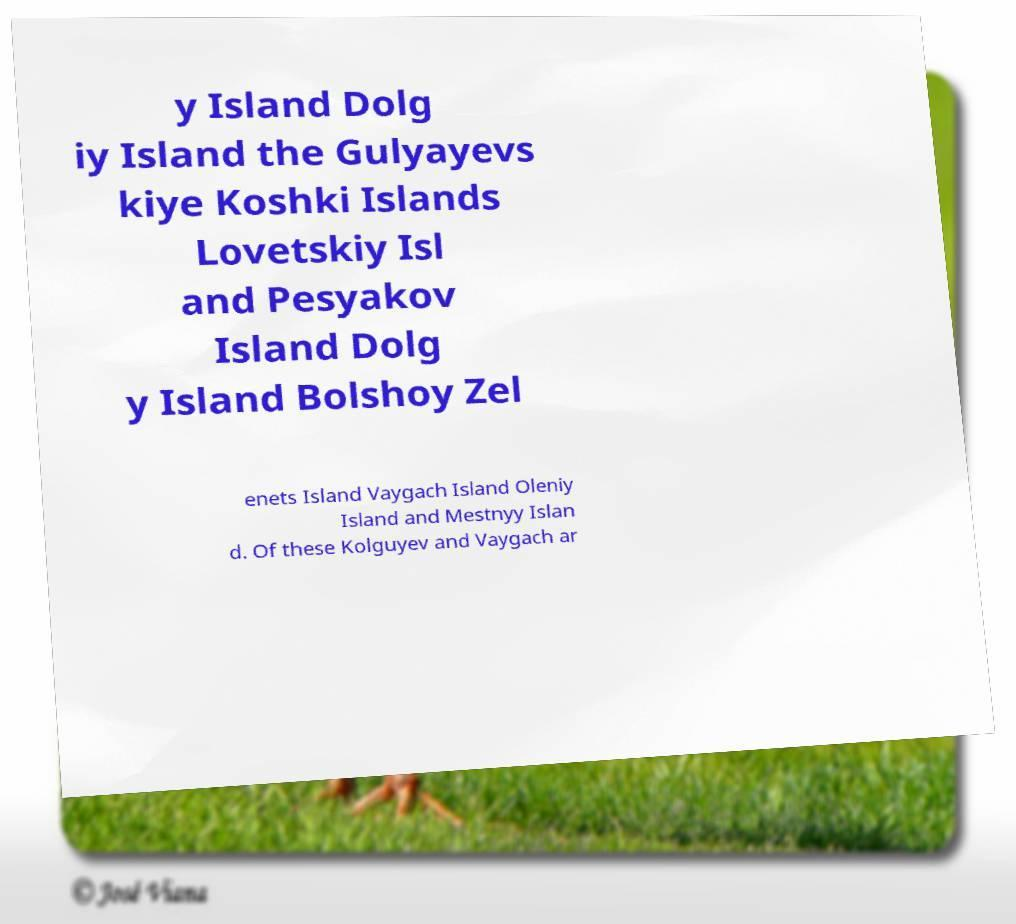What messages or text are displayed in this image? I need them in a readable, typed format. y Island Dolg iy Island the Gulyayevs kiye Koshki Islands Lovetskiy Isl and Pesyakov Island Dolg y Island Bolshoy Zel enets Island Vaygach Island Oleniy Island and Mestnyy Islan d. Of these Kolguyev and Vaygach ar 